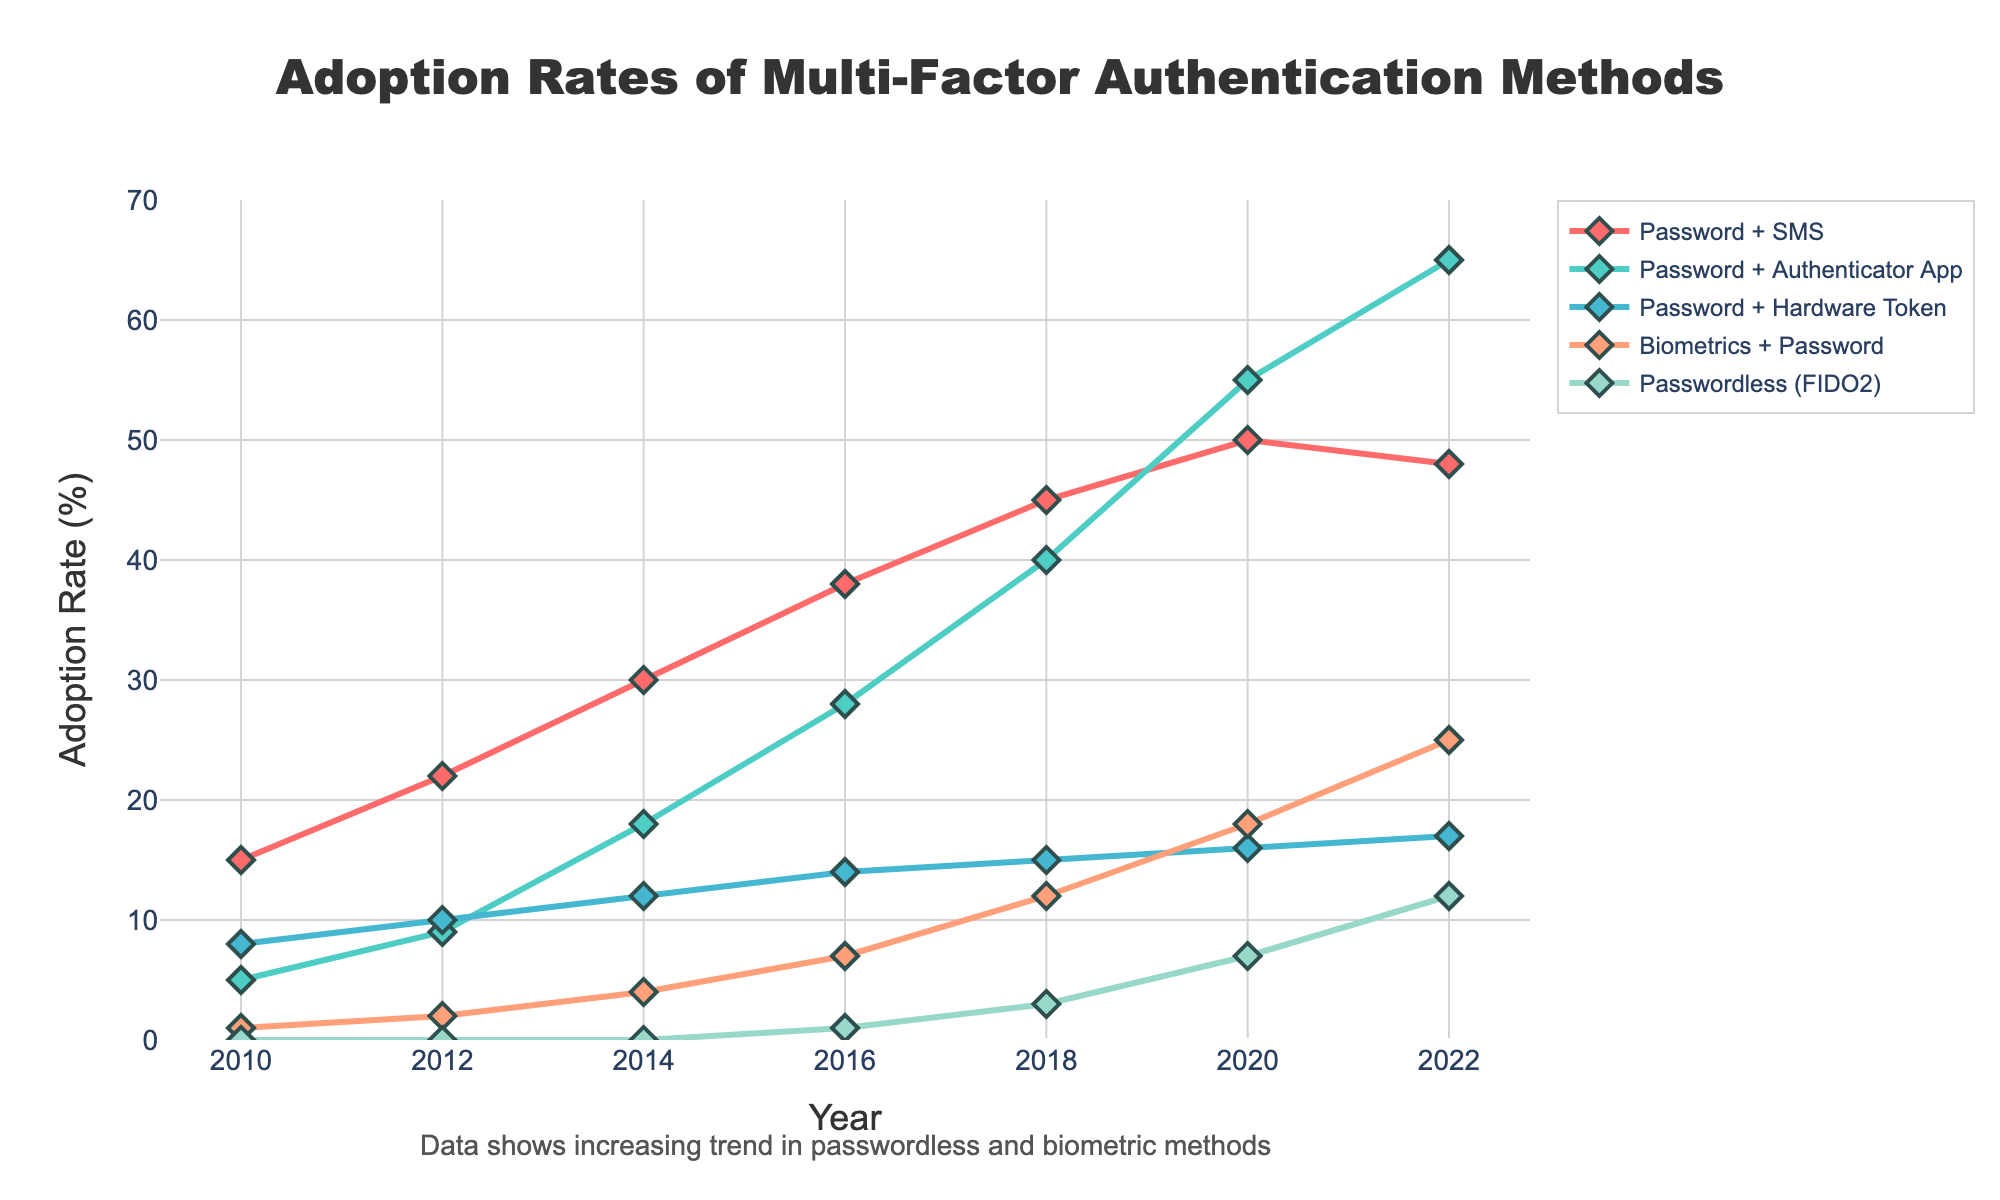What is the adoption rate for "Password + SMS" in 2012? Look at the line corresponding to "Password + SMS" and find the data point at the year 2012. The adoption rate is shown as 22%.
Answer: 22% Which authentication method shows the highest adoption rate in 2022? Check for the highest y-value among all the lines in 2022. The "Password + Authenticator App" line reaches an adoption rate of 65%, which is the highest.
Answer: Password + Authenticator App Compare the adoption rates of "Passwordless (FIDO2)" and "Biometrics + Password" in 2020. Which one is higher? Locate the adoption rates for "Passwordless (FIDO2)" and "Biometrics + Password" in 2020. "Passwordless (FIDO2)" has an adoption rate of 7%, while "Biometrics + Password" is at 18%. "Biometrics + Password" is higher.
Answer: Biometrics + Password What is the average adoption rate of "Password + Hardware Token" over the years? Sum up the adoption rates for "Password + Hardware Token" for each year and then divide by the number of years (7). Calculations: (8+10+12+14+15+16+17)/7 = 13.14.
Answer: 13.14% In which year did "Password + Authenticator App" surpass "Password + SMS" in terms of adoption rate? Track the "Password + Authenticator App" and "Password + SMS" lines and compare their values over the years. In 2020, "Password + Authenticator App" (55%) surpasses "Password + SMS" (50%) for the first time.
Answer: 2020 What is the total adoption rate of "Biometrics + Password" and "Passwordless (FIDO2)" combined in 2022? Add the adoption rates of "Biometrics + Password" (25%) and "Passwordless (FIDO2)" (12%) in 2022. Calculations: 25 + 12 = 37.
Answer: 37% How does the growth trend of "Passwordless (FIDO2)" compare to "Password + SMS" between 2016 and 2022? Look at the slope of the lines between 2016 and 2022 for "Passwordless (FIDO2)" and "Password + SMS". "Passwordless (FIDO2)" shows a continuous increase from 1% to 12%, while "Password + SMS" slightly decreases from 50% to 48%. "Passwordless (FIDO2)" is growing, "Password + SMS" is slightly decreasing.
Answer: Passwordless (FIDO2) is growing, Password + SMS is decreasing 